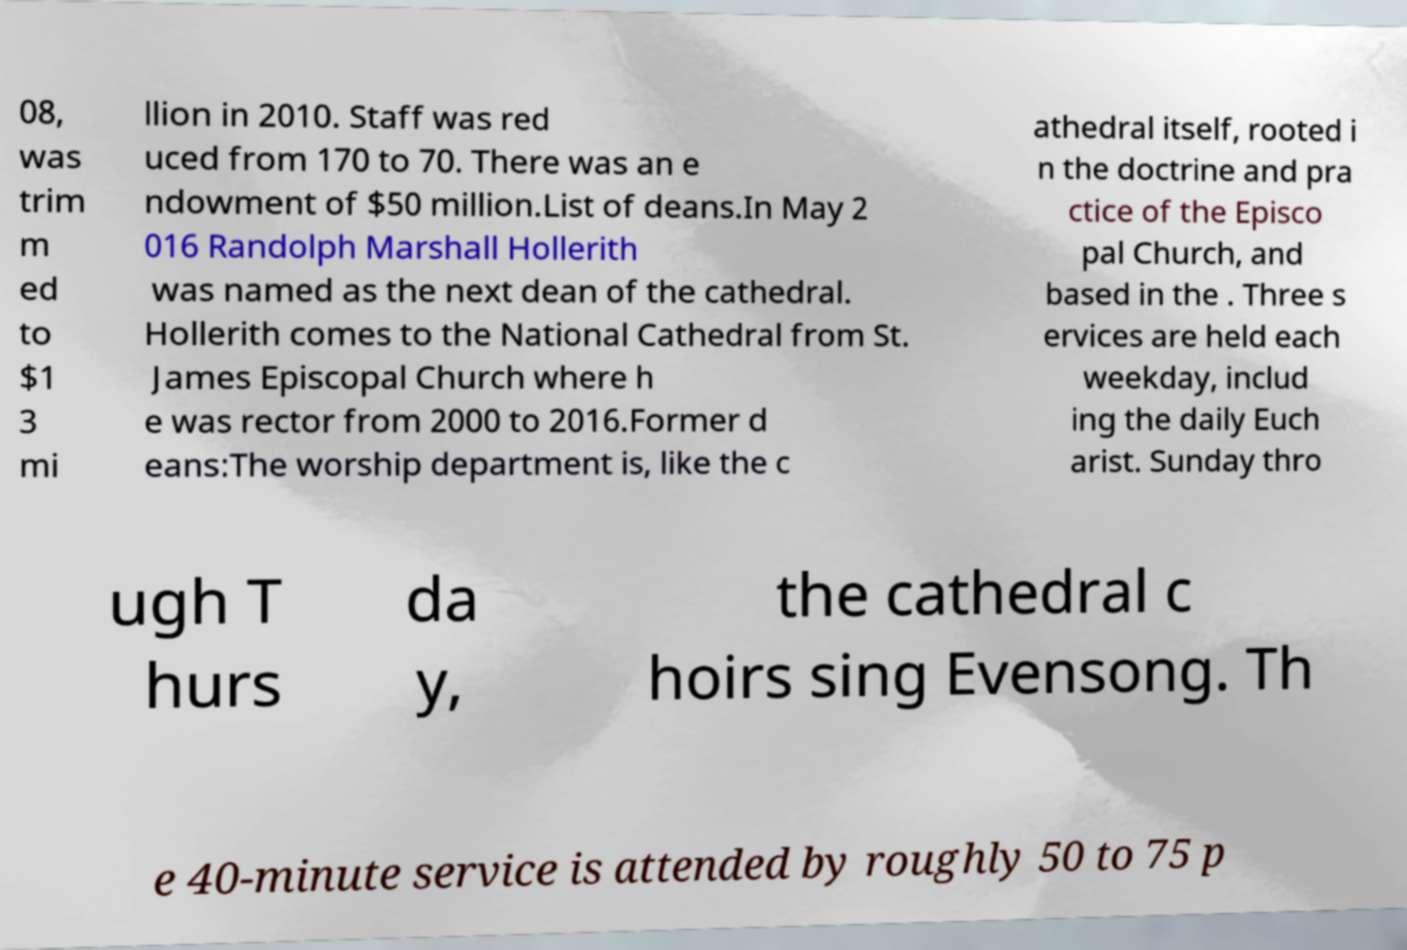For documentation purposes, I need the text within this image transcribed. Could you provide that? 08, was trim m ed to $1 3 mi llion in 2010. Staff was red uced from 170 to 70. There was an e ndowment of $50 million.List of deans.In May 2 016 Randolph Marshall Hollerith was named as the next dean of the cathedral. Hollerith comes to the National Cathedral from St. James Episcopal Church where h e was rector from 2000 to 2016.Former d eans:The worship department is, like the c athedral itself, rooted i n the doctrine and pra ctice of the Episco pal Church, and based in the . Three s ervices are held each weekday, includ ing the daily Euch arist. Sunday thro ugh T hurs da y, the cathedral c hoirs sing Evensong. Th e 40-minute service is attended by roughly 50 to 75 p 